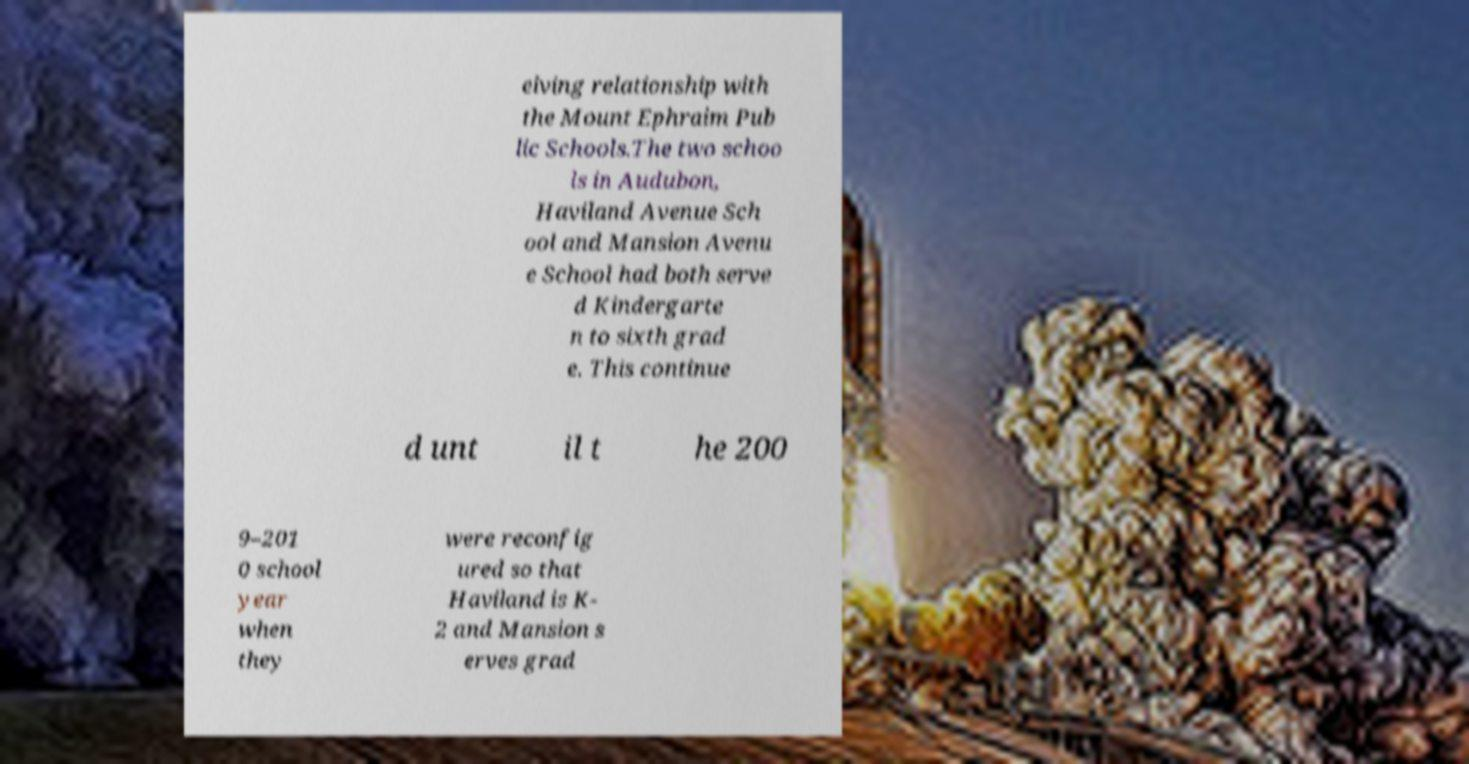Can you read and provide the text displayed in the image?This photo seems to have some interesting text. Can you extract and type it out for me? eiving relationship with the Mount Ephraim Pub lic Schools.The two schoo ls in Audubon, Haviland Avenue Sch ool and Mansion Avenu e School had both serve d Kindergarte n to sixth grad e. This continue d unt il t he 200 9–201 0 school year when they were reconfig ured so that Haviland is K- 2 and Mansion s erves grad 